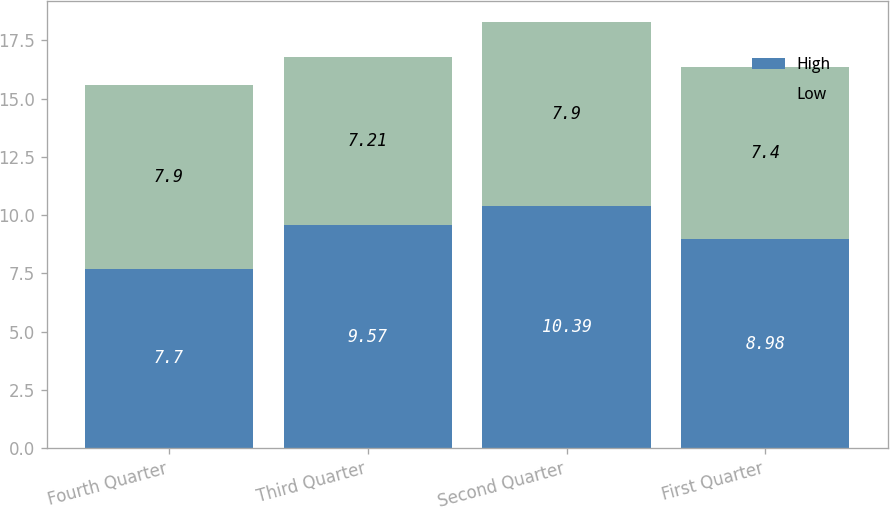<chart> <loc_0><loc_0><loc_500><loc_500><stacked_bar_chart><ecel><fcel>Fourth Quarter<fcel>Third Quarter<fcel>Second Quarter<fcel>First Quarter<nl><fcel>High<fcel>7.7<fcel>9.57<fcel>10.39<fcel>8.98<nl><fcel>Low<fcel>7.9<fcel>7.21<fcel>7.9<fcel>7.4<nl></chart> 